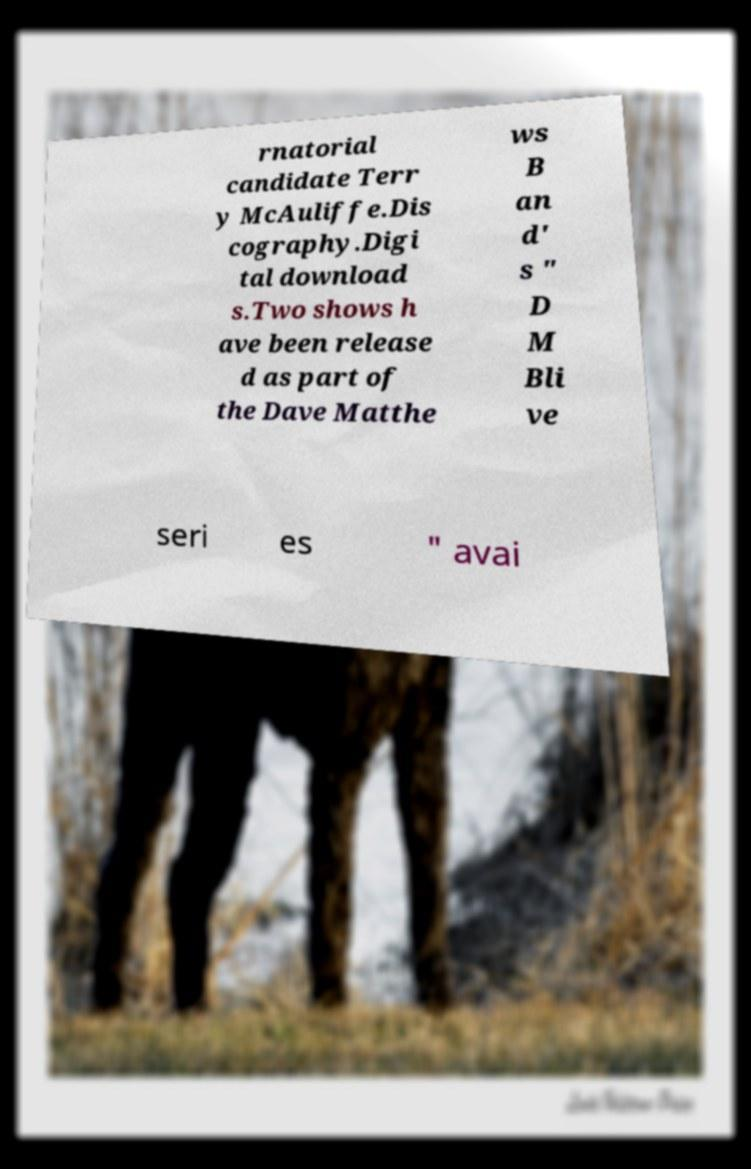Can you accurately transcribe the text from the provided image for me? rnatorial candidate Terr y McAuliffe.Dis cography.Digi tal download s.Two shows h ave been release d as part of the Dave Matthe ws B an d' s " D M Bli ve seri es " avai 